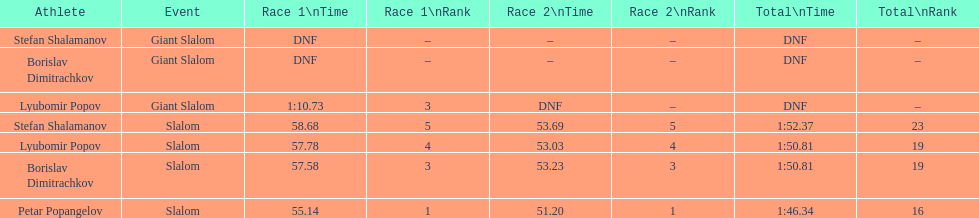Who was the other athlete who tied in rank with lyubomir popov? Borislav Dimitrachkov. 